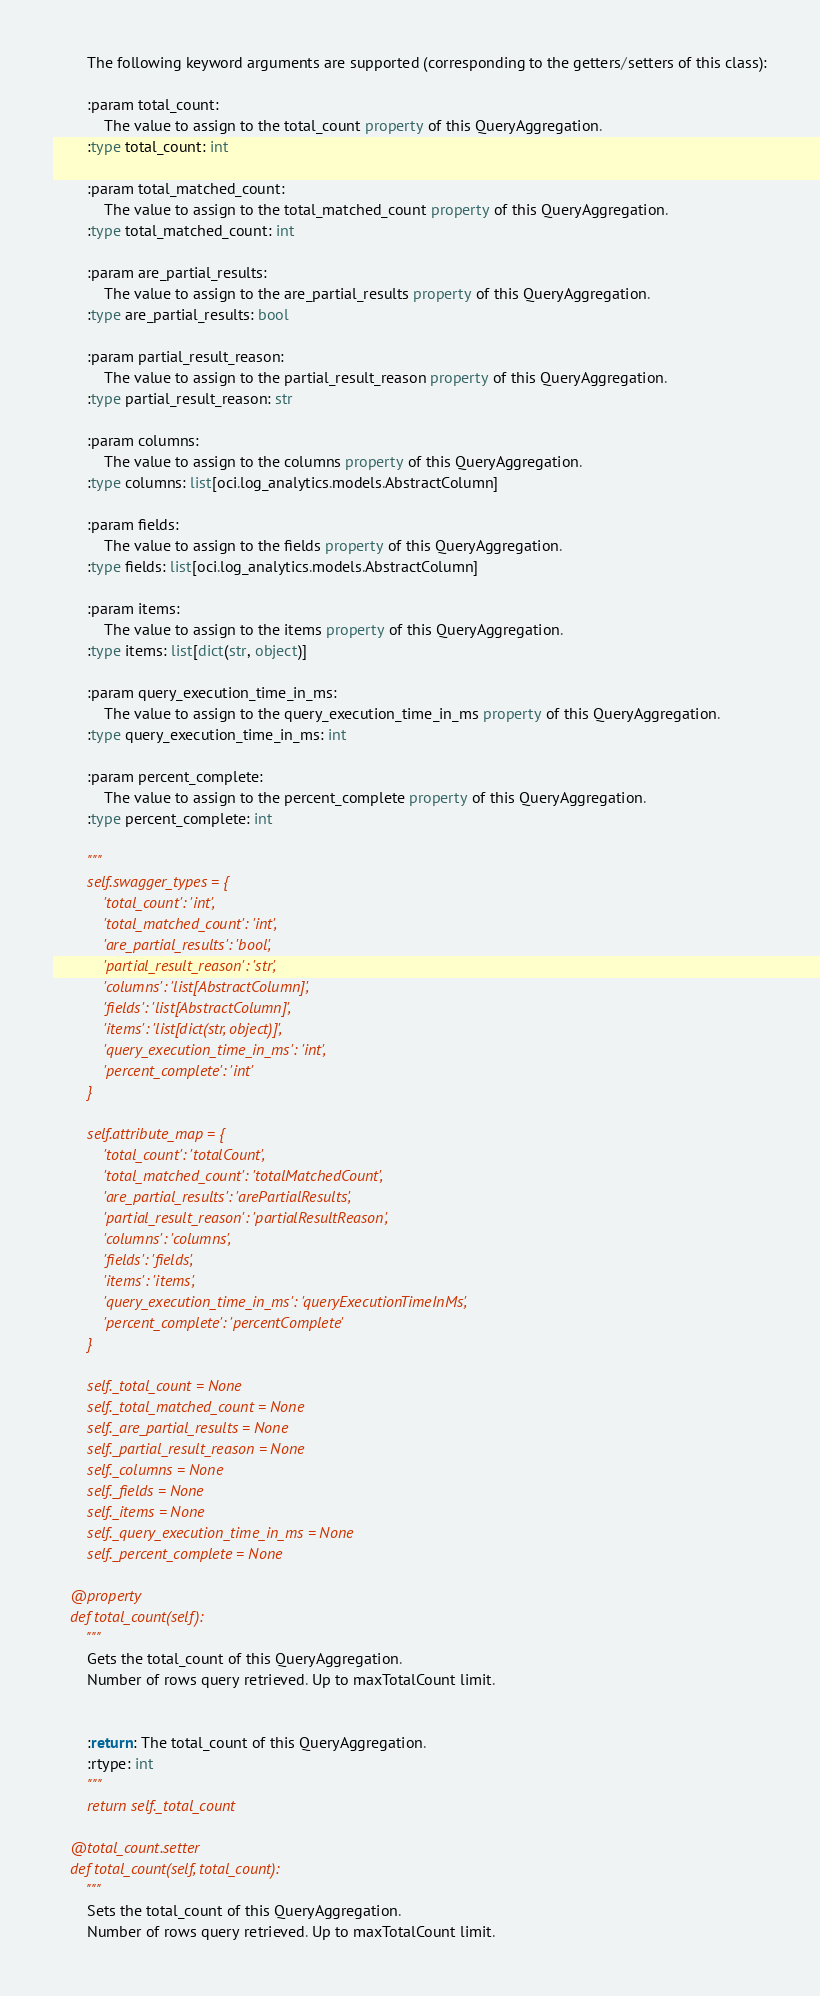Convert code to text. <code><loc_0><loc_0><loc_500><loc_500><_Python_>        The following keyword arguments are supported (corresponding to the getters/setters of this class):

        :param total_count:
            The value to assign to the total_count property of this QueryAggregation.
        :type total_count: int

        :param total_matched_count:
            The value to assign to the total_matched_count property of this QueryAggregation.
        :type total_matched_count: int

        :param are_partial_results:
            The value to assign to the are_partial_results property of this QueryAggregation.
        :type are_partial_results: bool

        :param partial_result_reason:
            The value to assign to the partial_result_reason property of this QueryAggregation.
        :type partial_result_reason: str

        :param columns:
            The value to assign to the columns property of this QueryAggregation.
        :type columns: list[oci.log_analytics.models.AbstractColumn]

        :param fields:
            The value to assign to the fields property of this QueryAggregation.
        :type fields: list[oci.log_analytics.models.AbstractColumn]

        :param items:
            The value to assign to the items property of this QueryAggregation.
        :type items: list[dict(str, object)]

        :param query_execution_time_in_ms:
            The value to assign to the query_execution_time_in_ms property of this QueryAggregation.
        :type query_execution_time_in_ms: int

        :param percent_complete:
            The value to assign to the percent_complete property of this QueryAggregation.
        :type percent_complete: int

        """
        self.swagger_types = {
            'total_count': 'int',
            'total_matched_count': 'int',
            'are_partial_results': 'bool',
            'partial_result_reason': 'str',
            'columns': 'list[AbstractColumn]',
            'fields': 'list[AbstractColumn]',
            'items': 'list[dict(str, object)]',
            'query_execution_time_in_ms': 'int',
            'percent_complete': 'int'
        }

        self.attribute_map = {
            'total_count': 'totalCount',
            'total_matched_count': 'totalMatchedCount',
            'are_partial_results': 'arePartialResults',
            'partial_result_reason': 'partialResultReason',
            'columns': 'columns',
            'fields': 'fields',
            'items': 'items',
            'query_execution_time_in_ms': 'queryExecutionTimeInMs',
            'percent_complete': 'percentComplete'
        }

        self._total_count = None
        self._total_matched_count = None
        self._are_partial_results = None
        self._partial_result_reason = None
        self._columns = None
        self._fields = None
        self._items = None
        self._query_execution_time_in_ms = None
        self._percent_complete = None

    @property
    def total_count(self):
        """
        Gets the total_count of this QueryAggregation.
        Number of rows query retrieved. Up to maxTotalCount limit.


        :return: The total_count of this QueryAggregation.
        :rtype: int
        """
        return self._total_count

    @total_count.setter
    def total_count(self, total_count):
        """
        Sets the total_count of this QueryAggregation.
        Number of rows query retrieved. Up to maxTotalCount limit.

</code> 